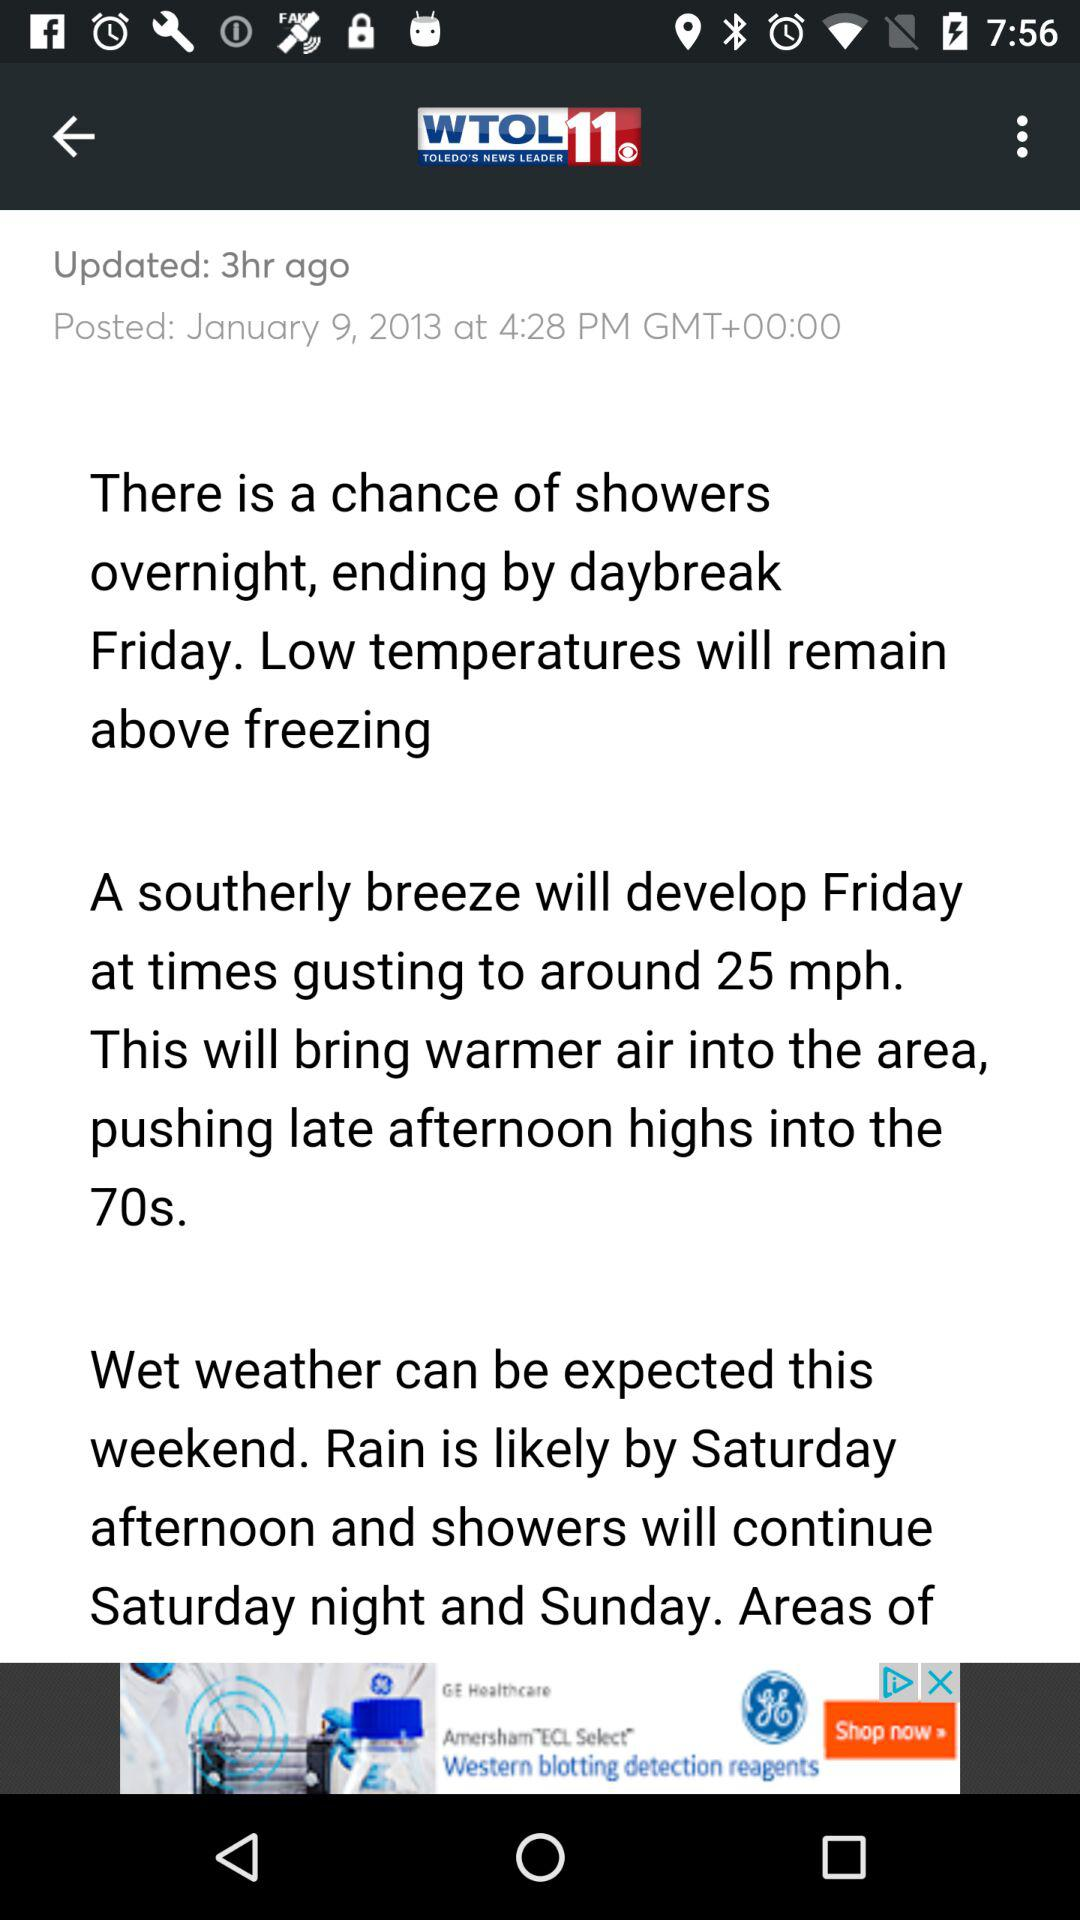What is the name of the application? The name of the application is "WTOL11". 